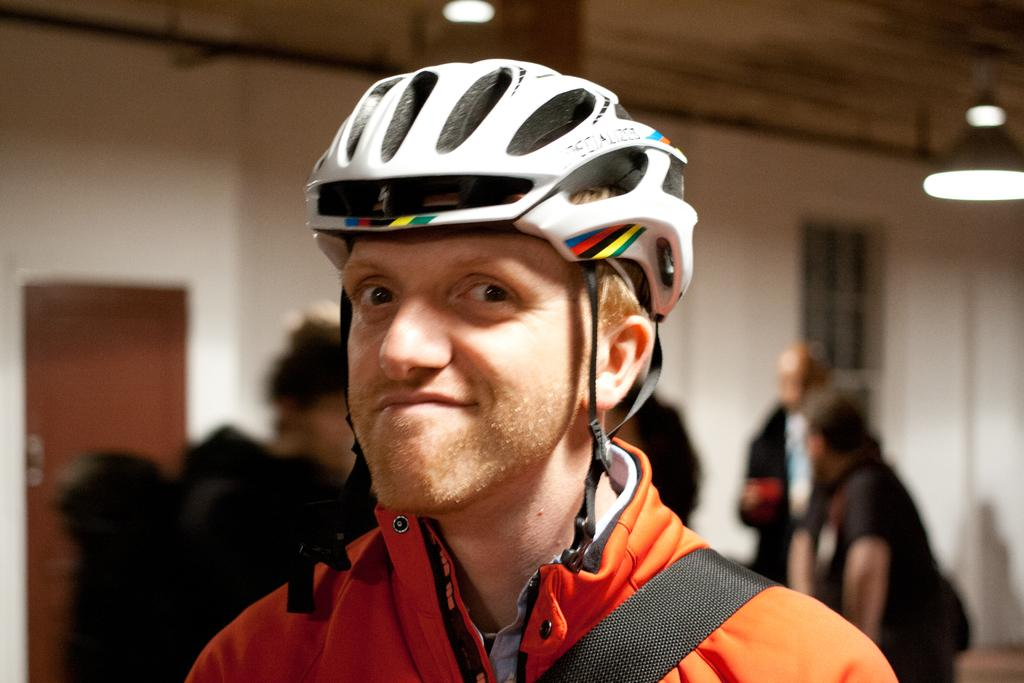What is the main subject of the image? There is a person in the image. What is the person wearing? The person is wearing an orange dress and a helmet. Can you describe the people in the background? The people in the background are visible but blurred. What type of crime is being committed in the image? There is no indication of a crime being committed in the image. 